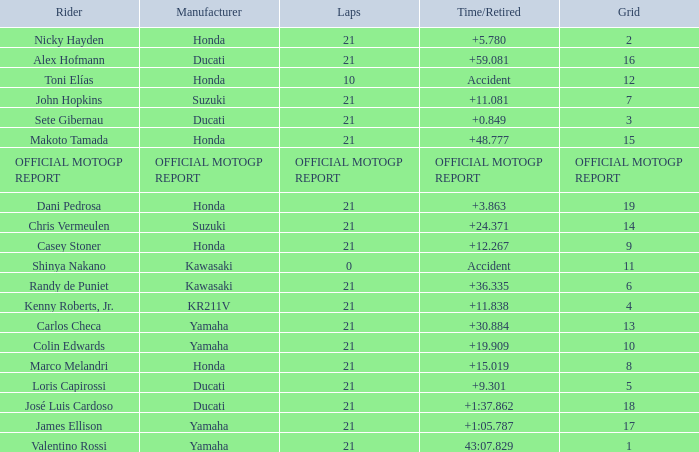How many laps did Valentino rossi have when riding a vehicle manufactured by yamaha? 21.0. 